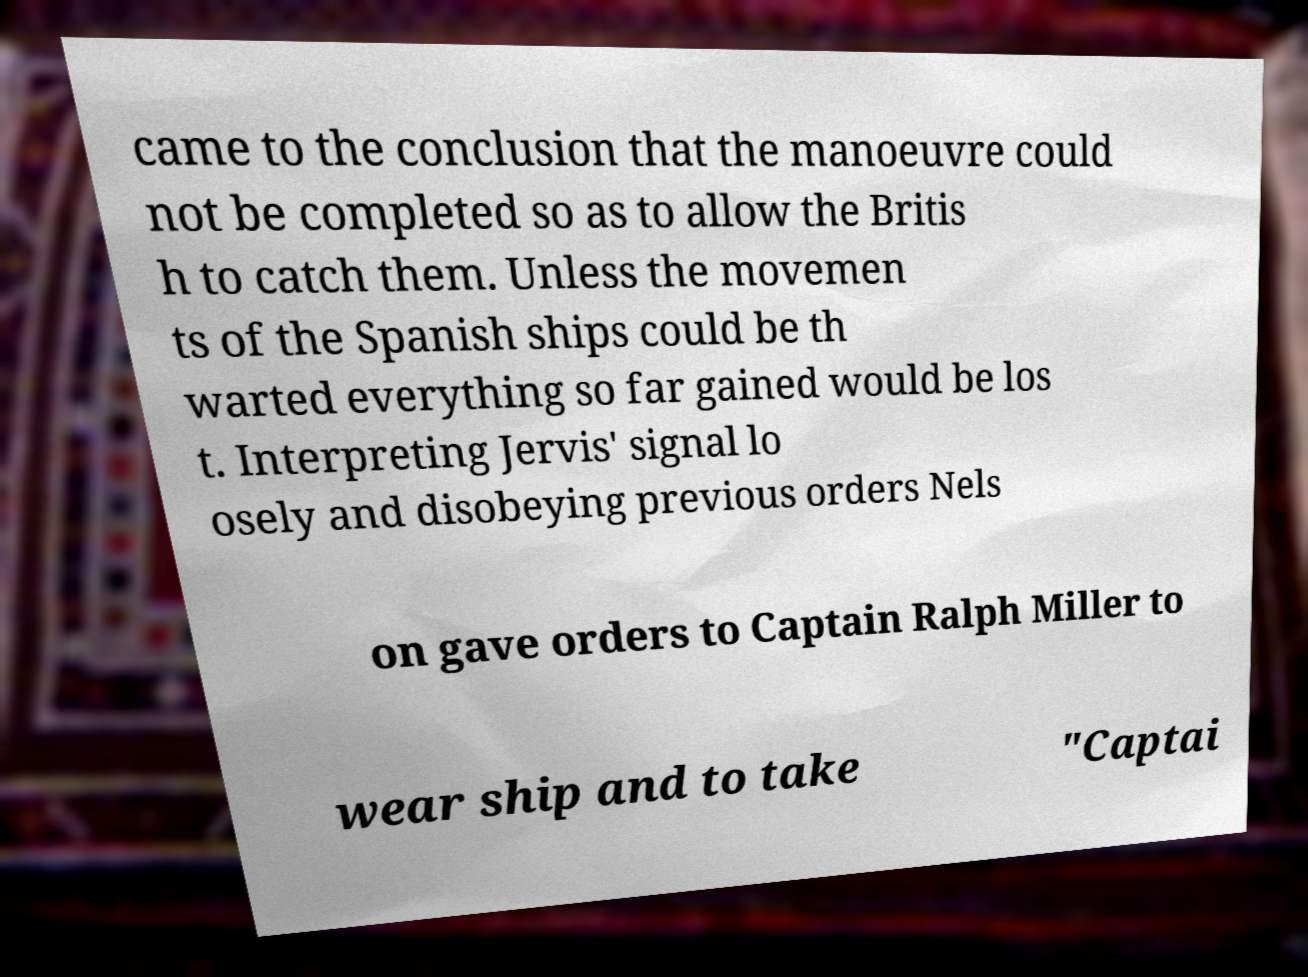There's text embedded in this image that I need extracted. Can you transcribe it verbatim? came to the conclusion that the manoeuvre could not be completed so as to allow the Britis h to catch them. Unless the movemen ts of the Spanish ships could be th warted everything so far gained would be los t. Interpreting Jervis' signal lo osely and disobeying previous orders Nels on gave orders to Captain Ralph Miller to wear ship and to take "Captai 